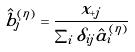Convert formula to latex. <formula><loc_0><loc_0><loc_500><loc_500>\hat { b } _ { j } ^ { ( \eta ) } = \frac { x _ { + j } } { \sum _ { i } \delta _ { i j } \hat { a } _ { i } ^ { ( \eta ) } }</formula> 